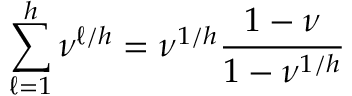<formula> <loc_0><loc_0><loc_500><loc_500>\sum _ { \ell = 1 } ^ { h } \nu ^ { \ell / h } = \nu ^ { 1 / h } \frac { 1 - \nu } { 1 - \nu ^ { 1 / h } }</formula> 